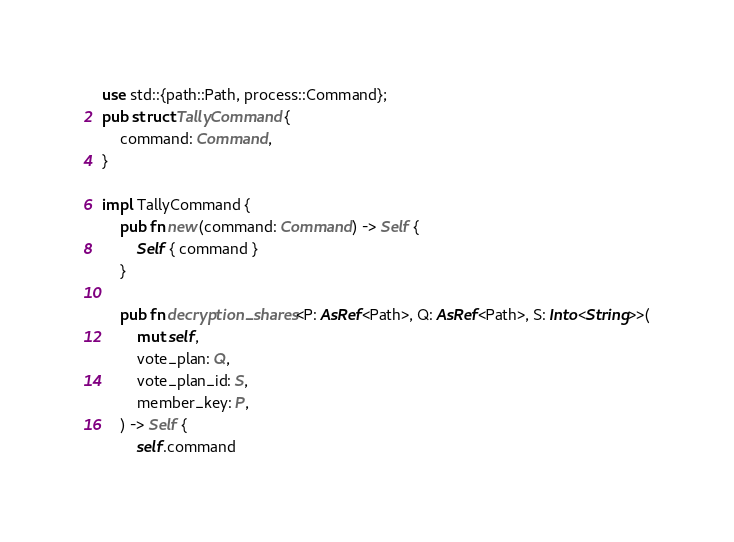Convert code to text. <code><loc_0><loc_0><loc_500><loc_500><_Rust_>use std::{path::Path, process::Command};
pub struct TallyCommand {
    command: Command,
}

impl TallyCommand {
    pub fn new(command: Command) -> Self {
        Self { command }
    }

    pub fn decryption_shares<P: AsRef<Path>, Q: AsRef<Path>, S: Into<String>>(
        mut self,
        vote_plan: Q,
        vote_plan_id: S,
        member_key: P,
    ) -> Self {
        self.command</code> 